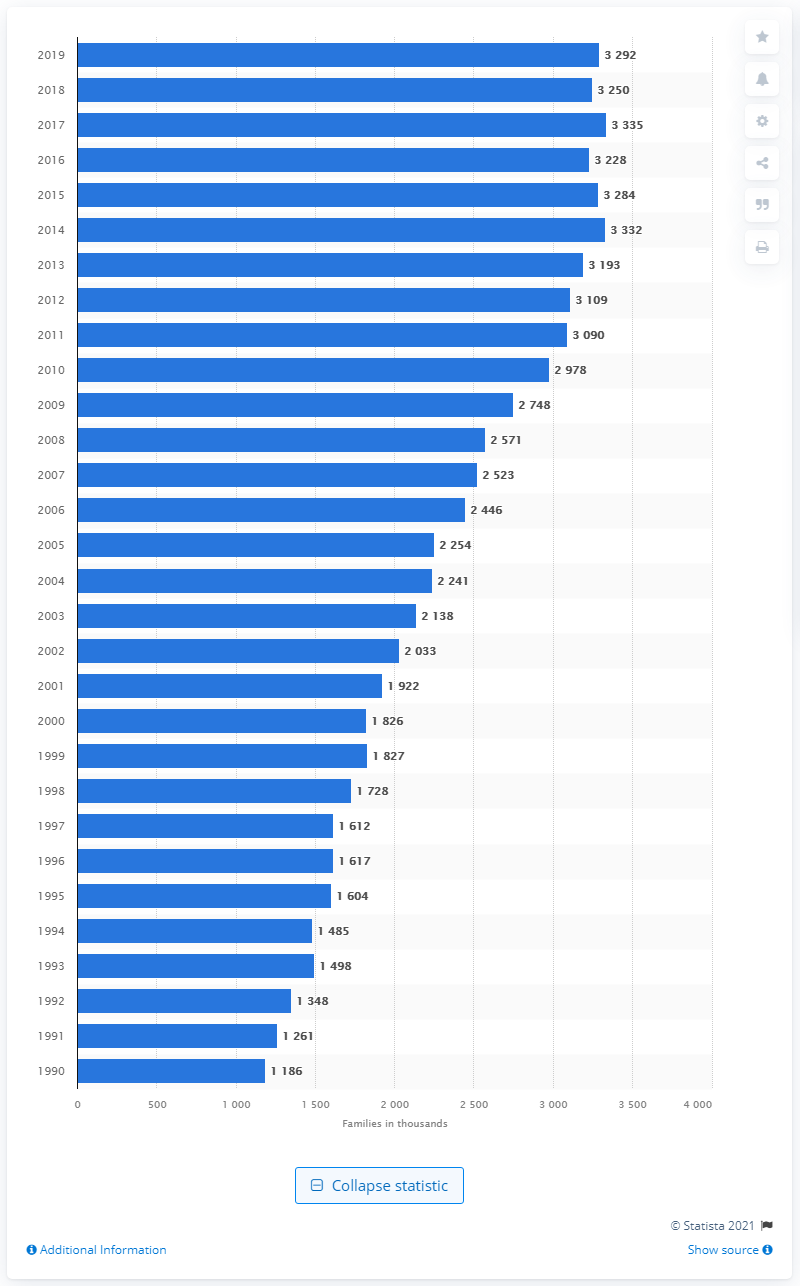List a handful of essential elements in this visual. In 1990, there were 1.19 million Hispanic families with a single mother living in the United States. 